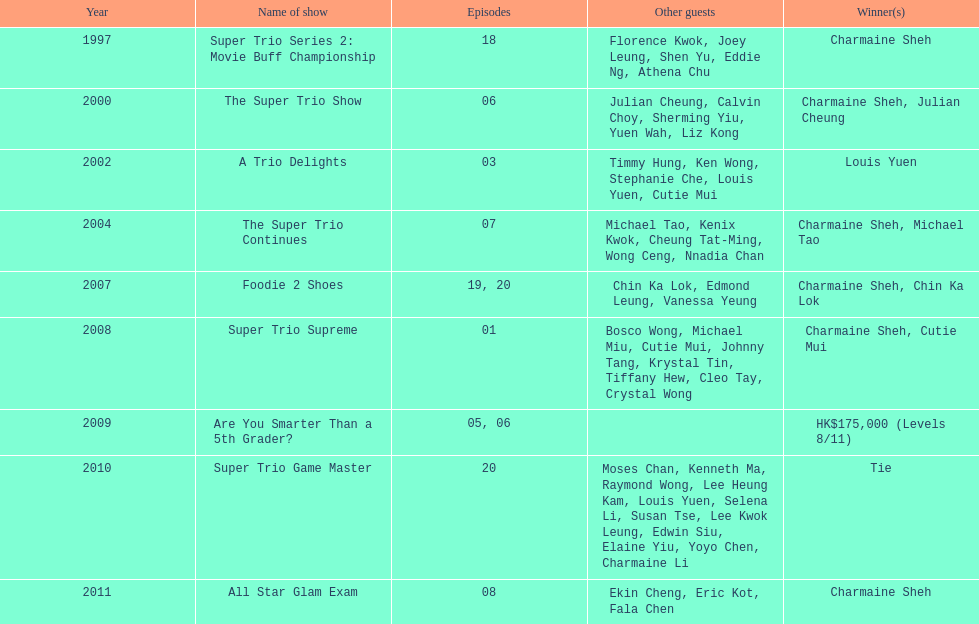In the variety show super trio 2: movie buff champions, how many episodes featured charmaine sheh? 18. 